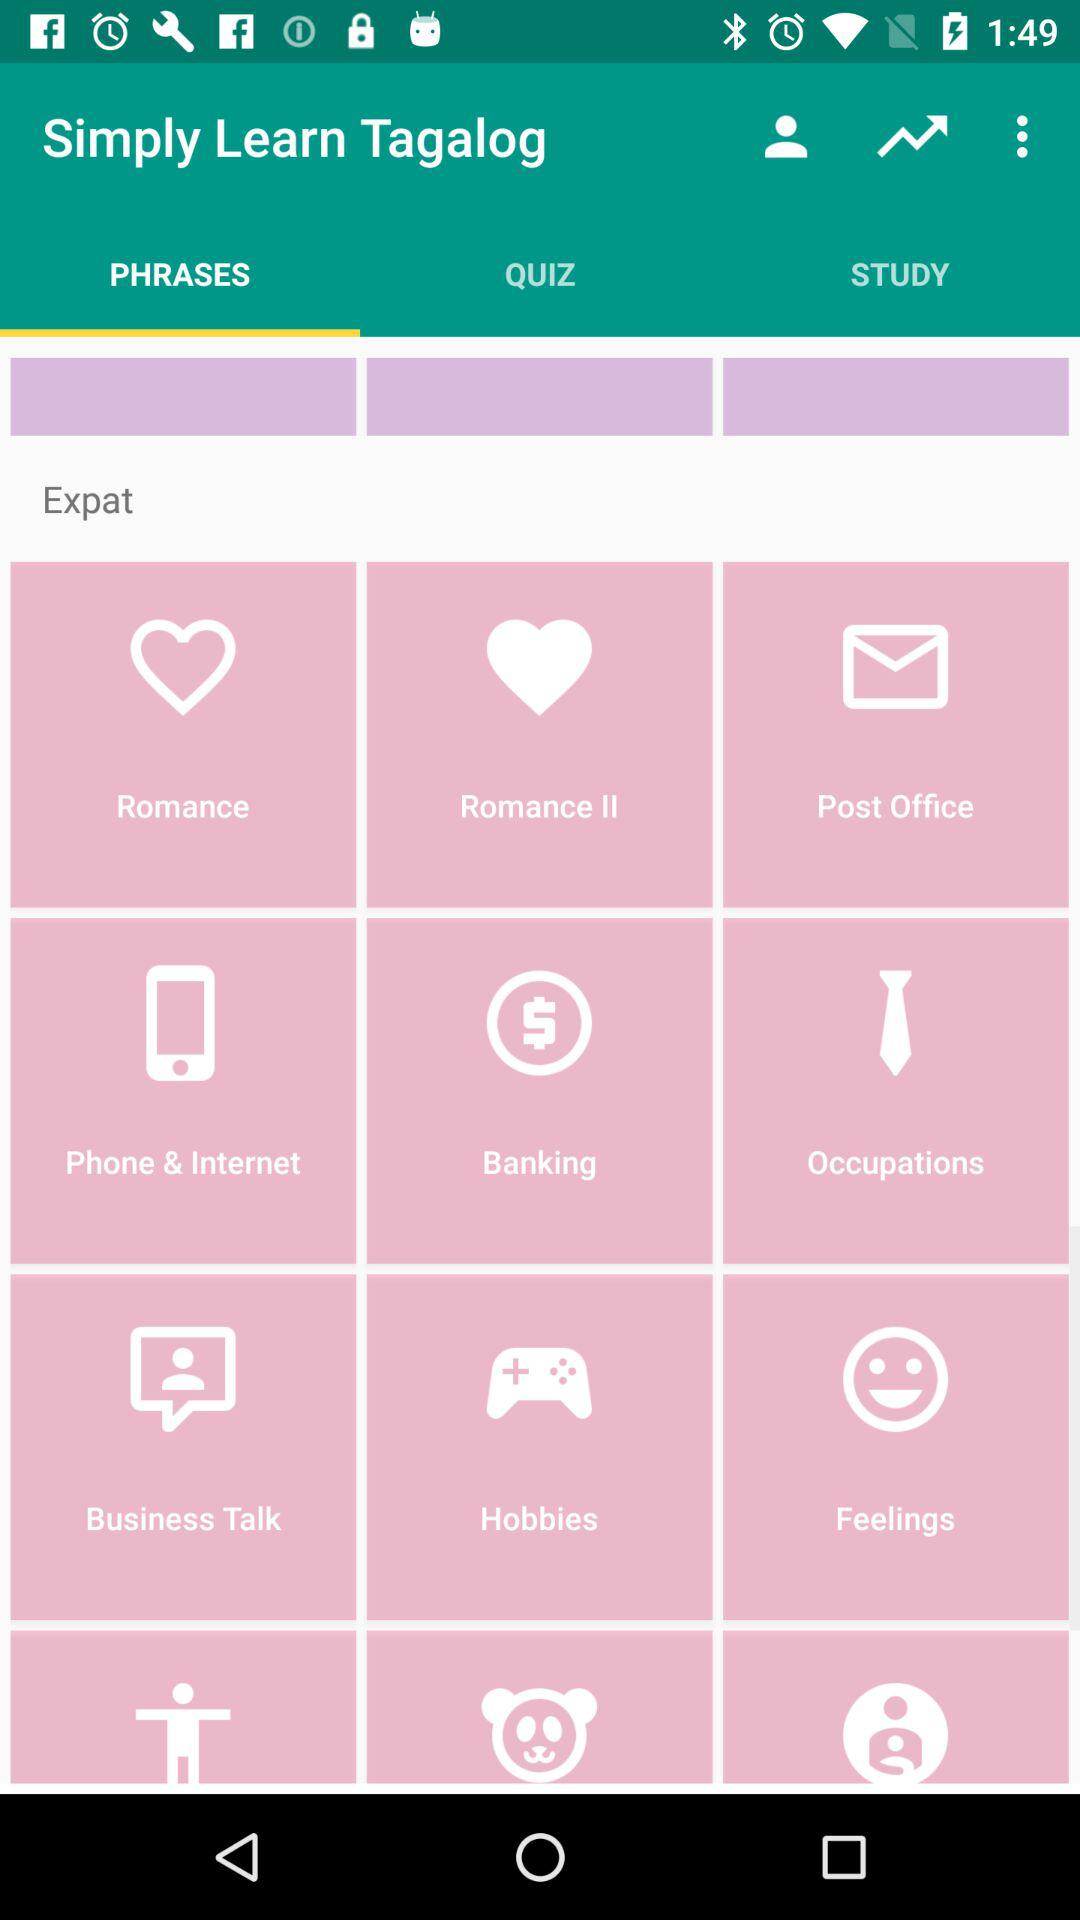Which option is selected? The selected option is "PHRASES". 